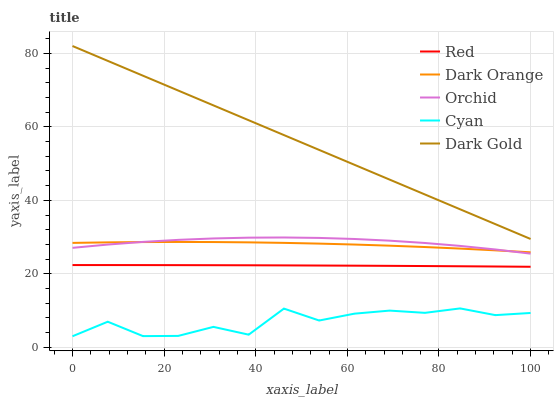Does Cyan have the minimum area under the curve?
Answer yes or no. Yes. Does Dark Gold have the minimum area under the curve?
Answer yes or no. No. Does Cyan have the maximum area under the curve?
Answer yes or no. No. Is Dark Gold the smoothest?
Answer yes or no. Yes. Is Cyan the roughest?
Answer yes or no. Yes. Is Cyan the smoothest?
Answer yes or no. No. Is Dark Gold the roughest?
Answer yes or no. No. Does Dark Gold have the lowest value?
Answer yes or no. No. Does Cyan have the highest value?
Answer yes or no. No. Is Cyan less than Red?
Answer yes or no. Yes. Is Dark Gold greater than Dark Orange?
Answer yes or no. Yes. Does Cyan intersect Red?
Answer yes or no. No. 